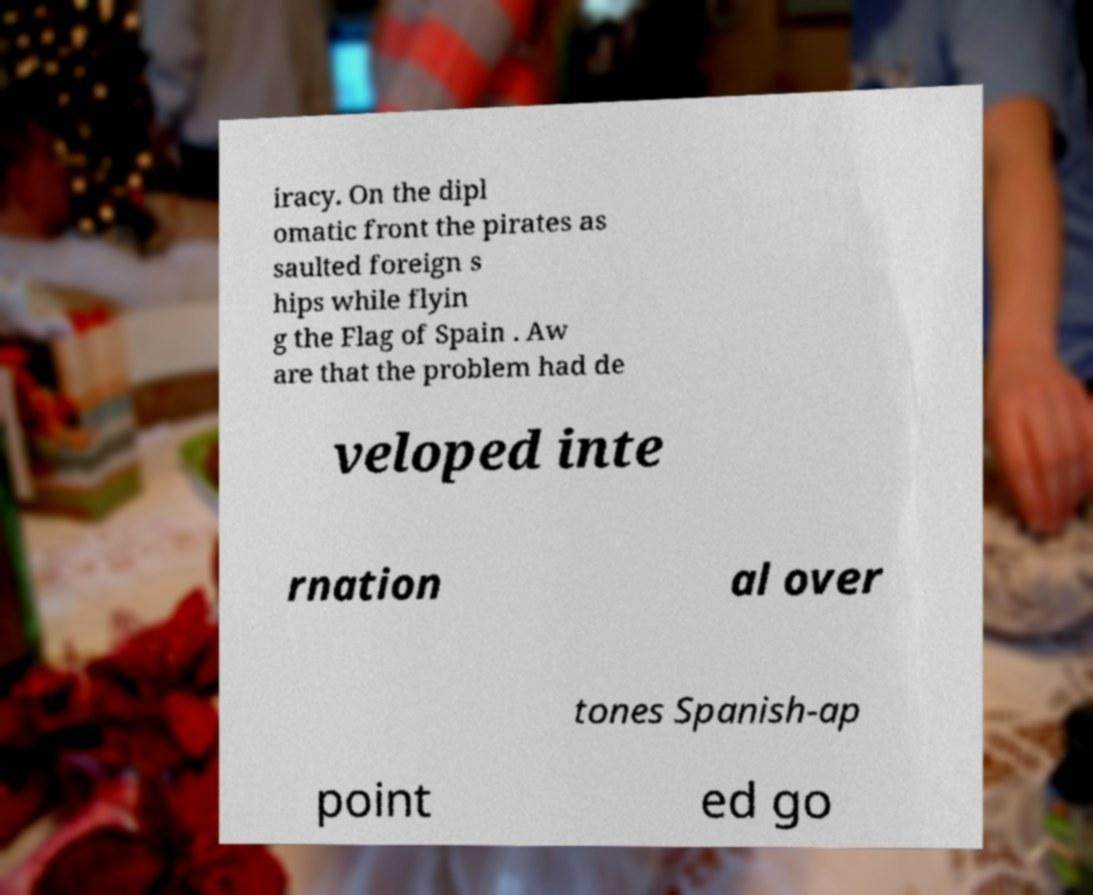Can you accurately transcribe the text from the provided image for me? iracy. On the dipl omatic front the pirates as saulted foreign s hips while flyin g the Flag of Spain . Aw are that the problem had de veloped inte rnation al over tones Spanish-ap point ed go 